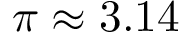<formula> <loc_0><loc_0><loc_500><loc_500>\pi \approx 3 . 1 4</formula> 